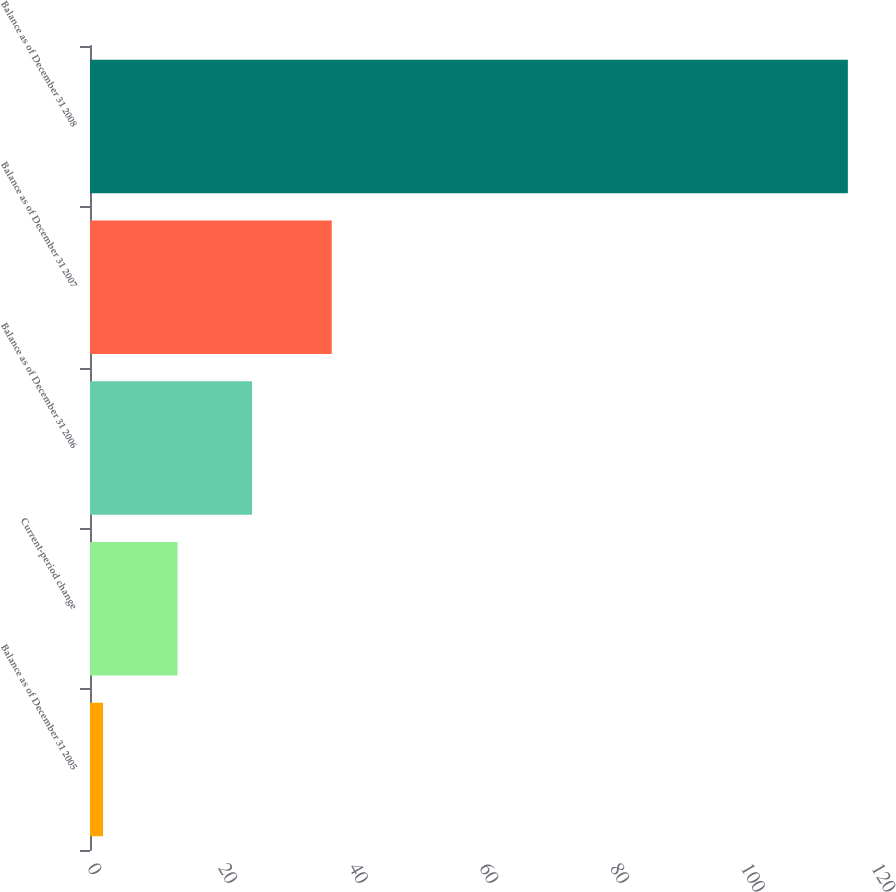Convert chart to OTSL. <chart><loc_0><loc_0><loc_500><loc_500><bar_chart><fcel>Balance as of December 31 2005<fcel>Current-period change<fcel>Balance as of December 31 2006<fcel>Balance as of December 31 2007<fcel>Balance as of December 31 2008<nl><fcel>2<fcel>13.4<fcel>24.8<fcel>37<fcel>116<nl></chart> 